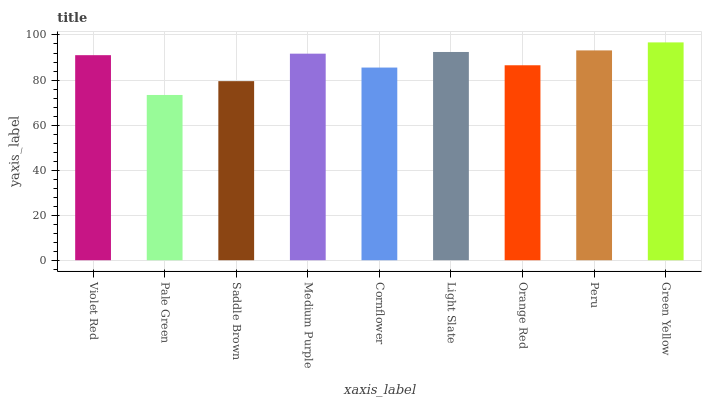Is Pale Green the minimum?
Answer yes or no. Yes. Is Green Yellow the maximum?
Answer yes or no. Yes. Is Saddle Brown the minimum?
Answer yes or no. No. Is Saddle Brown the maximum?
Answer yes or no. No. Is Saddle Brown greater than Pale Green?
Answer yes or no. Yes. Is Pale Green less than Saddle Brown?
Answer yes or no. Yes. Is Pale Green greater than Saddle Brown?
Answer yes or no. No. Is Saddle Brown less than Pale Green?
Answer yes or no. No. Is Violet Red the high median?
Answer yes or no. Yes. Is Violet Red the low median?
Answer yes or no. Yes. Is Medium Purple the high median?
Answer yes or no. No. Is Pale Green the low median?
Answer yes or no. No. 